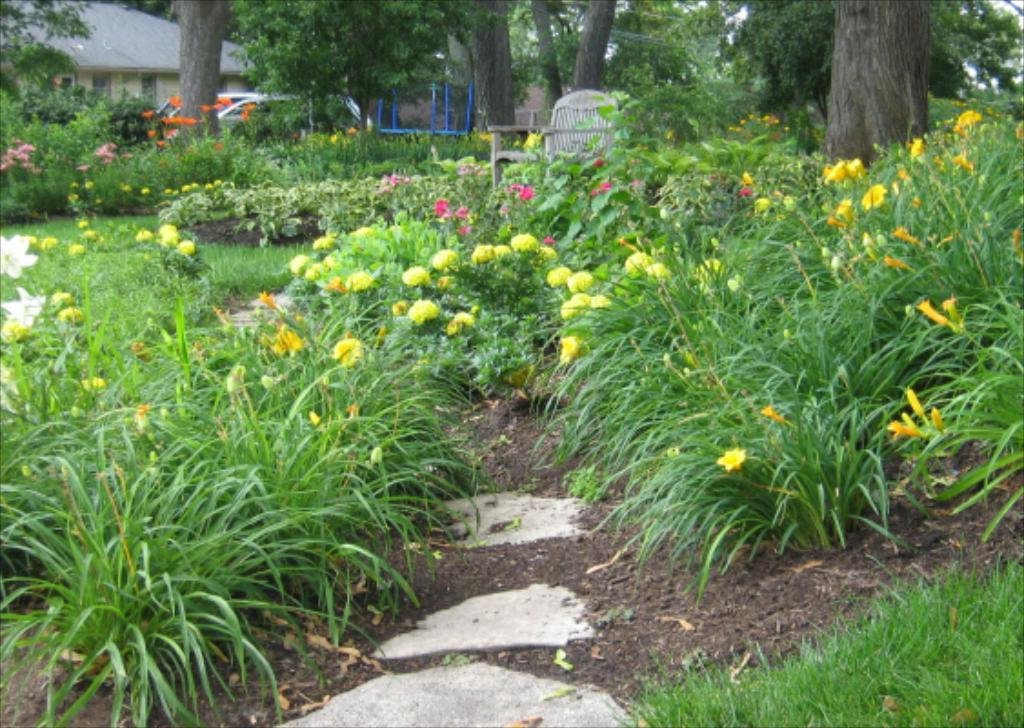What type of ground covering is visible in the image? The ground is covered with grass. What type of vegetation can be seen in the image? There are plants, flowers, and trees in the image. What type of seating is present in the image? There is a chair in the image. What type of flooring is visible in the image? There are tiles in the image. What type of objects are on the ground in the image? There are objects on the ground in the image. What type of transportation is present in the image? There is a vehicle in the image. What type of structure is present in the image? There is a building in the image. Where is the hydrant located in the image? There is no hydrant present in the image. What type of throat is visible in the image? There is no throat present in the image. 